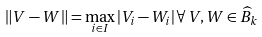Convert formula to latex. <formula><loc_0><loc_0><loc_500><loc_500>\| V - W \| = \max _ { i \in I } | V _ { i } - W _ { i } | \, \forall \, V , W \in \widehat { B } _ { k }</formula> 